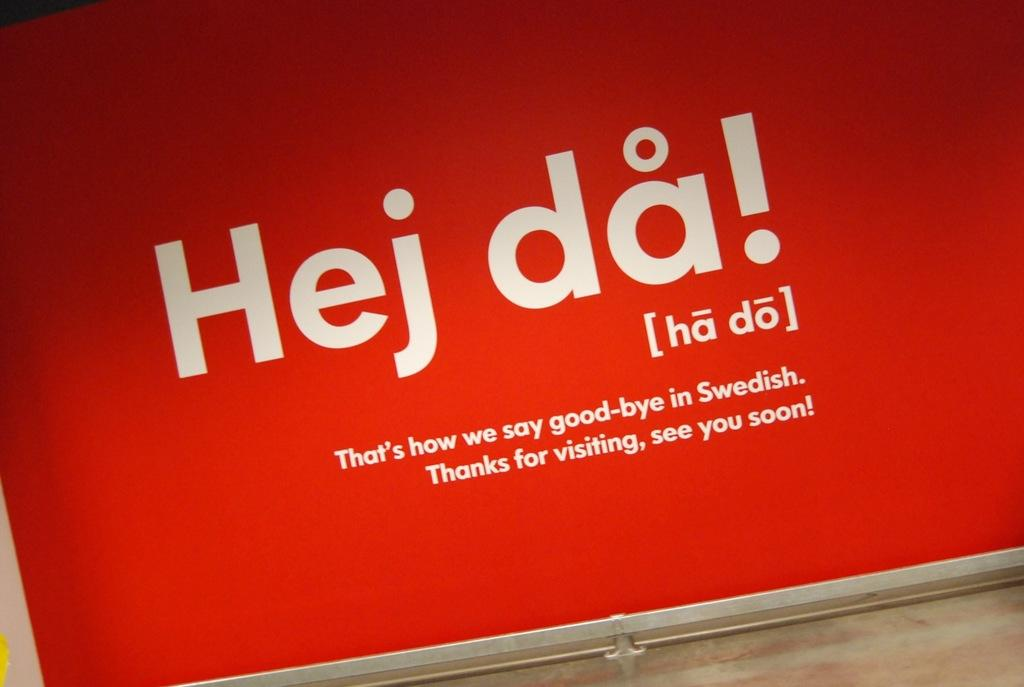<image>
Write a terse but informative summary of the picture. A sign shows how to say good bye in the Swedish language. 